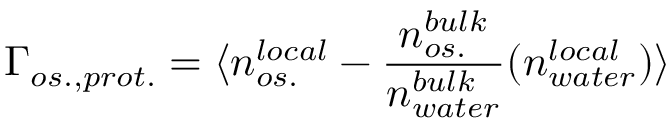<formula> <loc_0><loc_0><loc_500><loc_500>\Gamma _ { o s . , p r o t . } = \langle n _ { o s . } ^ { l o c a l } - \frac { n _ { o s . } ^ { b u l k } } { n _ { w a t e r } ^ { b u l k } } ( n _ { w a t e r } ^ { l o c a l } ) \rangle</formula> 